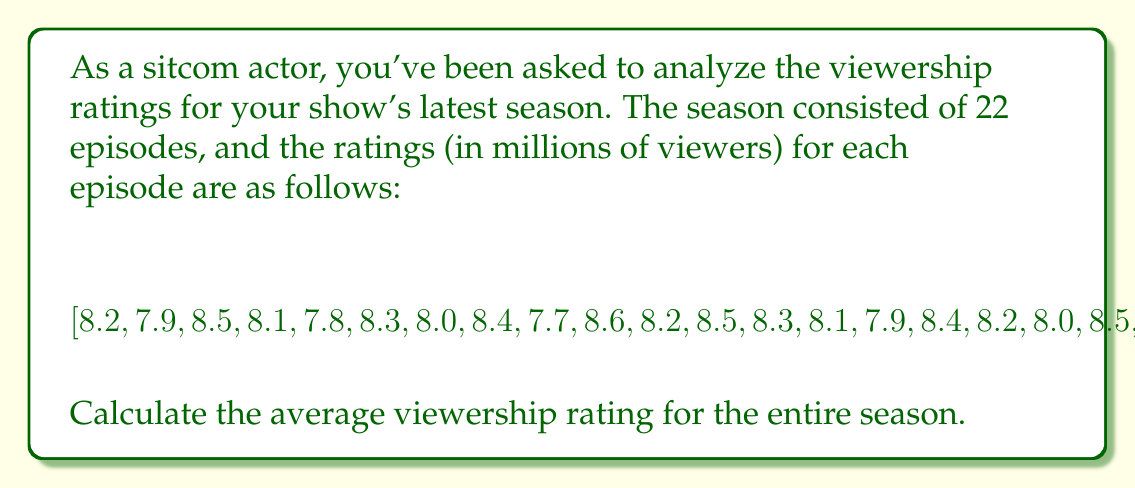Show me your answer to this math problem. To calculate the average viewership rating for the season, we need to follow these steps:

1) Sum up all the ratings:
   $$\text{Sum} = 8.2 + 7.9 + 8.5 + 8.1 + 7.8 + 8.3 + 8.0 + 8.4 + 7.7 + 8.6 + 8.2 + 8.5 + 8.3 + 8.1 + 7.9 + 8.4 + 8.2 + 8.0 + 8.5 + 8.3 + 8.1 + 8.7$$

2) Count the total number of episodes:
   $$\text{Number of episodes} = 22$$

3) Calculate the average by dividing the sum by the number of episodes:
   $$\text{Average} = \frac{\text{Sum}}{\text{Number of episodes}}$$

4) Perform the calculation:
   $$\text{Sum} = 180.7$$
   $$\text{Average} = \frac{180.7}{22} \approx 8.2136$$

5) Round to two decimal places:
   $$\text{Average} \approx 8.21 \text{ million viewers}$$
Answer: 8.21 million viewers 